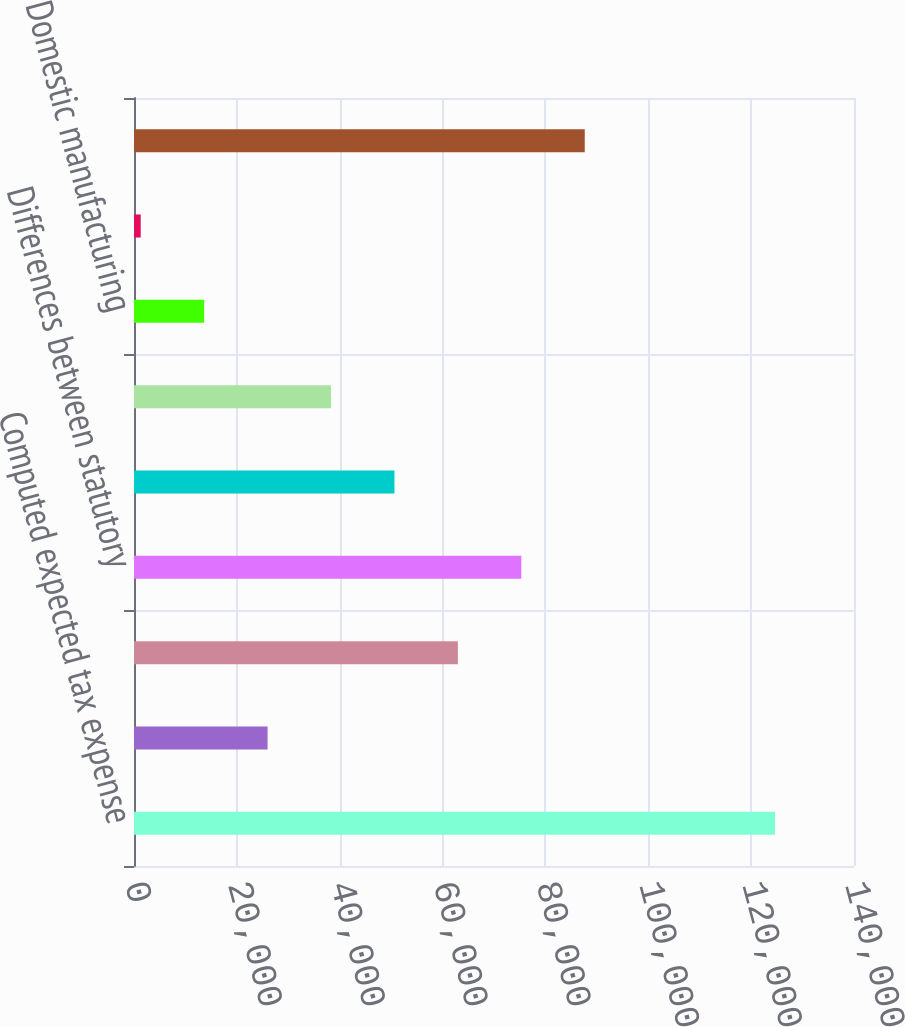Convert chart to OTSL. <chart><loc_0><loc_0><loc_500><loc_500><bar_chart><fcel>Computed expected tax expense<fcel>State tax expense net of<fcel>Tax credits<fcel>Differences between statutory<fcel>Stock-based compensation (net<fcel>Resolution of income tax<fcel>Domestic manufacturing<fcel>Other net<fcel>Provision for income taxes<nl><fcel>124649<fcel>25974.6<fcel>62977.5<fcel>75311.8<fcel>50643.2<fcel>38308.9<fcel>13640.3<fcel>1306<fcel>87646.1<nl></chart> 